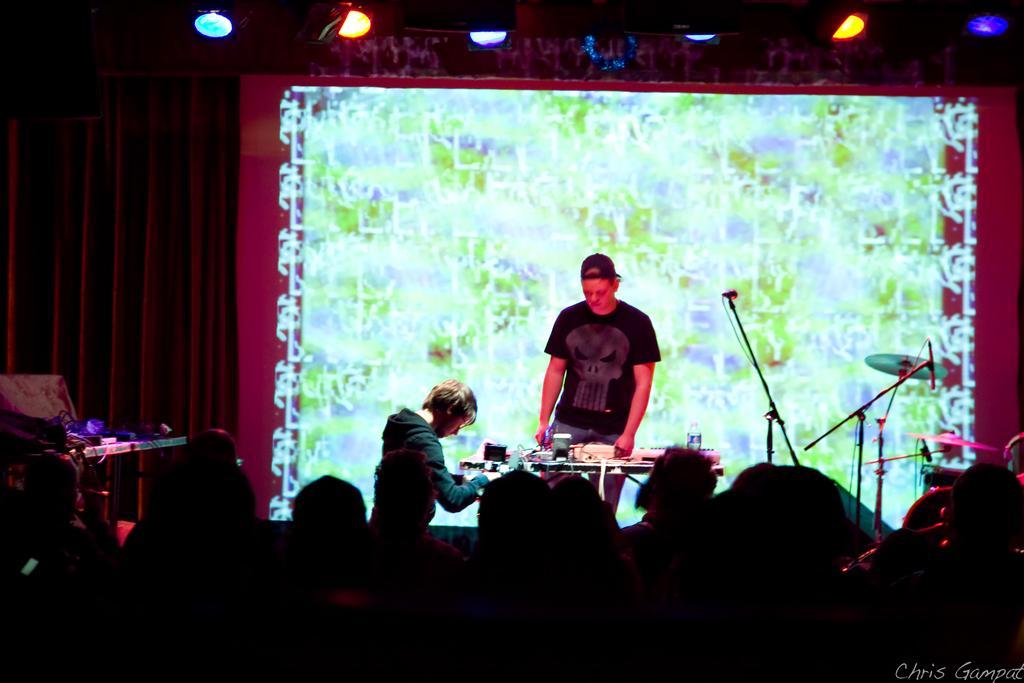Can you describe this image briefly? As we can see in the image there are few people here and there, screen, lights, tables, musical drums and light. 